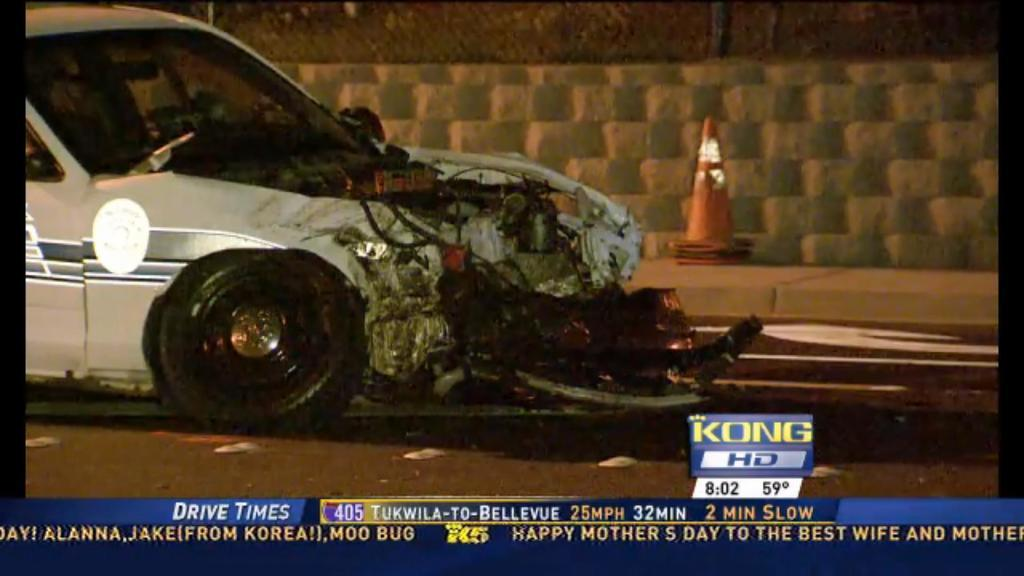<image>
Create a compact narrative representing the image presented. The TV is tuned to the channel KONG HD. 